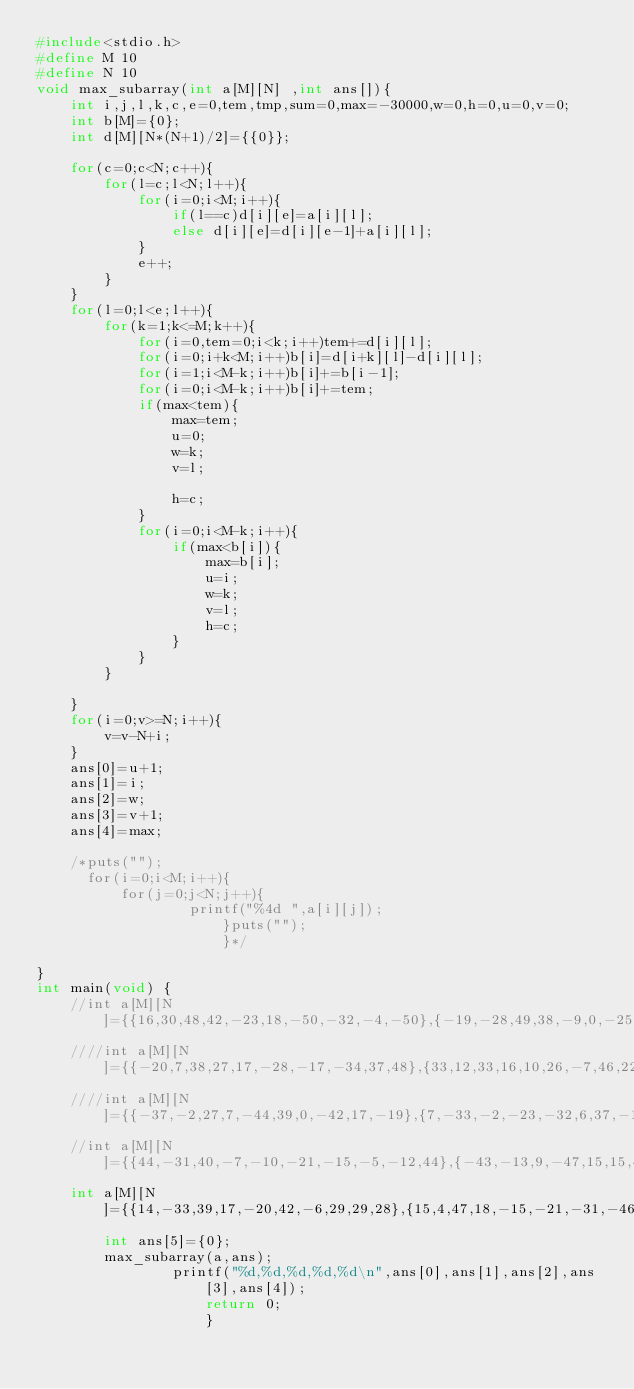Convert code to text. <code><loc_0><loc_0><loc_500><loc_500><_C_>#include<stdio.h>
#define M 10
#define N 10
void max_subarray(int a[M][N] ,int ans[]){
    int i,j,l,k,c,e=0,tem,tmp,sum=0,max=-30000,w=0,h=0,u=0,v=0;
    int b[M]={0};
    int d[M][N*(N+1)/2]={{0}};

    for(c=0;c<N;c++){
        for(l=c;l<N;l++){
            for(i=0;i<M;i++){
                if(l==c)d[i][e]=a[i][l];
                else d[i][e]=d[i][e-1]+a[i][l];
            }
            e++;
        }
    }
    for(l=0;l<e;l++){
        for(k=1;k<=M;k++){
            for(i=0,tem=0;i<k;i++)tem+=d[i][l];
            for(i=0;i+k<M;i++)b[i]=d[i+k][l]-d[i][l];
            for(i=1;i<M-k;i++)b[i]+=b[i-1];
            for(i=0;i<M-k;i++)b[i]+=tem;
            if(max<tem){
                max=tem;
                u=0;
                w=k;
                v=l;

                h=c;
            }
            for(i=0;i<M-k;i++){
                if(max<b[i]){
                    max=b[i];
                    u=i;
                    w=k;
                    v=l;
                    h=c;
                }
            }
        }

    }
    for(i=0;v>=N;i++){
        v=v-N+i;
    }
    ans[0]=u+1;
    ans[1]=i;
    ans[2]=w;
    ans[3]=v+1;
    ans[4]=max;

    /*puts("");
      for(i=0;i<M;i++){
          for(j=0;j<N;j++){
                  printf("%4d ",a[i][j]);
                      }puts("");
                      }*/

}
int main(void) {
    //int a[M][N]={{16,30,48,42,-23,18,-50,-32,-4,-50},{-19,-28,49,38,-9,0,-25,10,36,-28},{48,-10,47,-24,-36,8,45,-30,24,17},{16,-49,-48,11,-17,28,-39,-45,24,1},{-27,-44,1,21,-28,24,3,6,-9,-1},{-1,-40,41,-23,-17,-19,14,48,41,49},{17,20,-40,43,-26,44,-24,-32,16,-49},{-4,-26,-31,7,15,-46,-28,33,-16,-39},{12,49,-41,49,-21,-39,-45,40,14,-1},{26,-31,8,36,22,-42,-45,9,-17,-42}};
    ////int a[M][N]={{-20,7,38,27,17,-28,-17,-34,37,48},{33,12,33,16,10,26,-7,46,22,49},{9,-8,11,10,-26,-13,4,-48,36,-4},{3,34,21,-30,37,18,-15,20,-33,26},{-46,-29,-8,-34,-28,39,26,38,-39,-1},{40,-10,-30,-5,-35,44,9,10,47,11},{15,-27,30,18,44,-41,-13,7,7,-33},{-22,-6,40,44,19,-22,-4,-29,14,-44},{-29,44,-49,-29,49,-25,-27,12,7,-50},{11,-23,-1,17,-5,33,-5,-31,-1,13}};
    ////int a[M][N]={{-37,-2,27,7,-44,39,0,-42,17,-19},{7,-33,-2,-23,-32,6,37,-18,49,-10},{-26,-42,-42,46,-7,41,8,40,-15,16},{-30,-16,-47,-3,49,-10,14,30,-47,-35},{-44,-4,-11,0,6,-41,8,-5,-36,-9},{30,-35,16,-46,31,10,14,29,26,20},{21,17,10,48,15,31,-21,23,33,-29},{-29,15,48,22,-27,-48,-20,-5,6,-29},{42,-14,35,-14,45,13,-1,-42,38,30},{-38,-34,14,9,8,45,46,-41,3,-17}};
    //int a[M][N]={{44,-31,40,-7,-10,-21,-15,-5,-12,44},{-43,-13,9,-47,15,15,49,43,12,6},{26,17,31,-11,1,44,31,-18,-34,-26},{-2,33,6,-16,45,30,-21,29,7,-33},{-5,12,45,2,23,-11,-8,-39,-37,29},{47,-48,27,-19,-32,-49,24,6,24,-24},{-8,-34,11,-10,-32,14,30,-11,-47,0},{-23,23,31,-40,45,9,18,12,-42,39},{-49,37,-29,37,-50,-12,15,-33,6,46},{-44,47,6,-16,-49,-25,43,-24,-38,17}};
    int a[M][N]={{14,-33,39,17,-20,42,-6,29,29,28},{15,4,47,18,-15,-21,-31,-46,-25,-16},{45,38,3,-38,-33,-44,9,-5,-4,-37},{46,-20,13,9,-28,-33,-45,8,-13,33},{40,-48,5,-11,-37,26,-7,16,-40,7},{21,-5,44,17,-28,20,-19,-1,12,27},{-41,-27,37,16,10,38,-46,-6,-21,17},{12,1,2,-16,45,-31,2,31,-33,-36},{-15,-46,-24,10,-46,22,6,-31,-11,49},{-41,-13,-22,-26,-13,-28,39,-25,-11,-31}};
        int ans[5]={0};
        max_subarray(a,ans);
                printf("%d,%d,%d,%d,%d\n",ans[0],ans[1],ans[2],ans[3],ans[4]);
                    return 0;
                    }</code> 